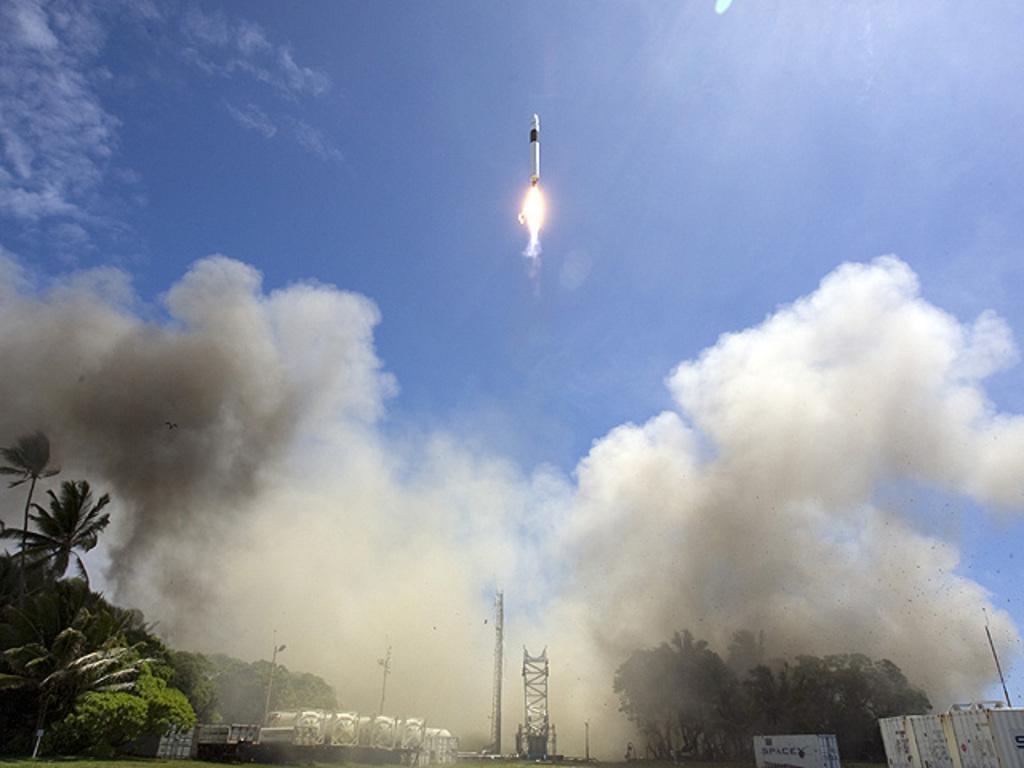What is flying in the sky in the image? There is a missile flying in the sky in the image. What can be seen in the background of the image? There is a group of trees, buildings, and containers in the background. What is the condition of the sky in the image? The sky is cloudy in the image. What type of bone can be seen growing out of the missile in the image? There is no bone present in the image, and the missile is not depicted as growing anything. 